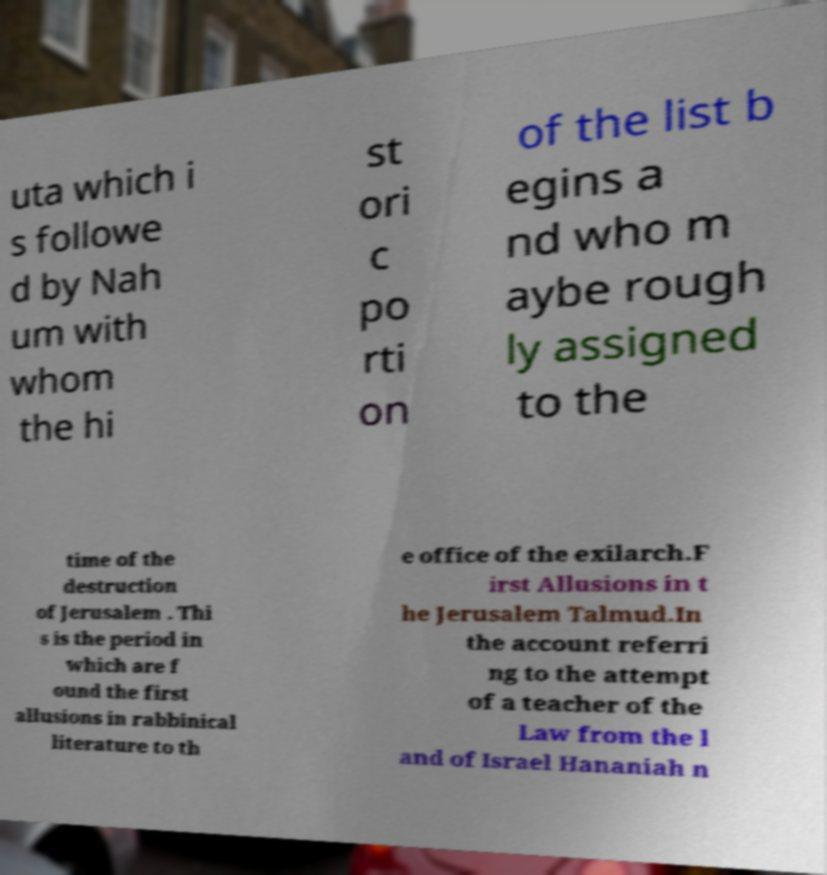Could you assist in decoding the text presented in this image and type it out clearly? uta which i s followe d by Nah um with whom the hi st ori c po rti on of the list b egins a nd who m aybe rough ly assigned to the time of the destruction of Jerusalem . Thi s is the period in which are f ound the first allusions in rabbinical literature to th e office of the exilarch.F irst Allusions in t he Jerusalem Talmud.In the account referri ng to the attempt of a teacher of the Law from the l and of Israel Hananiah n 